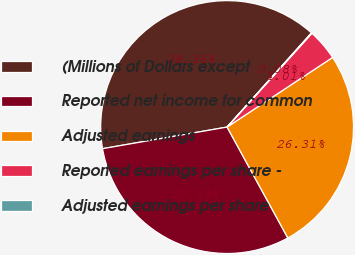Convert chart to OTSL. <chart><loc_0><loc_0><loc_500><loc_500><pie_chart><fcel>(Millions of Dollars except<fcel>Reported net income for common<fcel>Adjusted earnings<fcel>Reported earnings per share -<fcel>Adjusted earnings per share<nl><fcel>39.36%<fcel>30.24%<fcel>26.31%<fcel>4.01%<fcel>0.08%<nl></chart> 